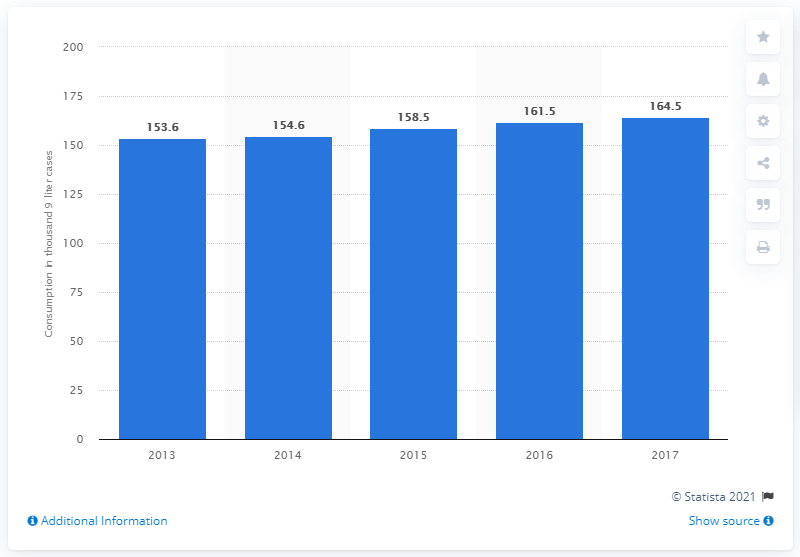List a handful of essential elements in this visual. In 2017, a total of 164.5 liters of spirits were consumed in Canada. The previous year, a total of 161.5 liters of spirits were consumed in Canada. 